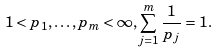<formula> <loc_0><loc_0><loc_500><loc_500>1 < p _ { 1 } , \dots , p _ { m } < \infty , \sum _ { j = 1 } ^ { m } \frac { 1 } { p _ { j } } = 1 .</formula> 